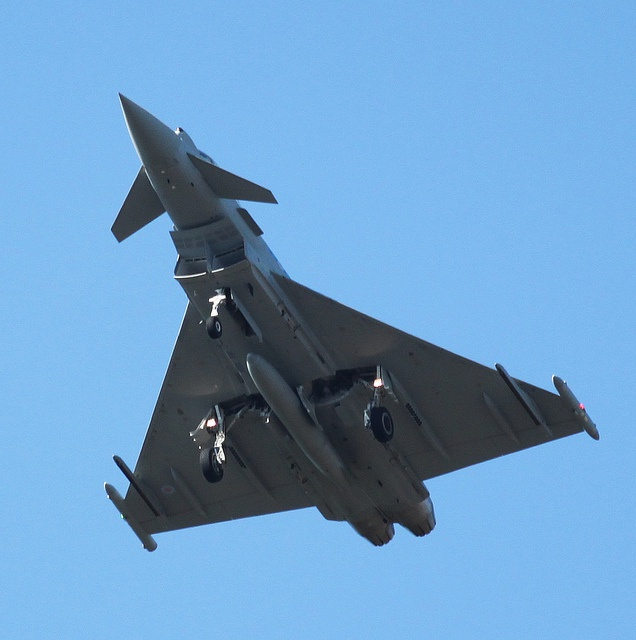Describe the objects in this image and their specific colors. I can see a airplane in lightblue, black, darkblue, and gray tones in this image. 